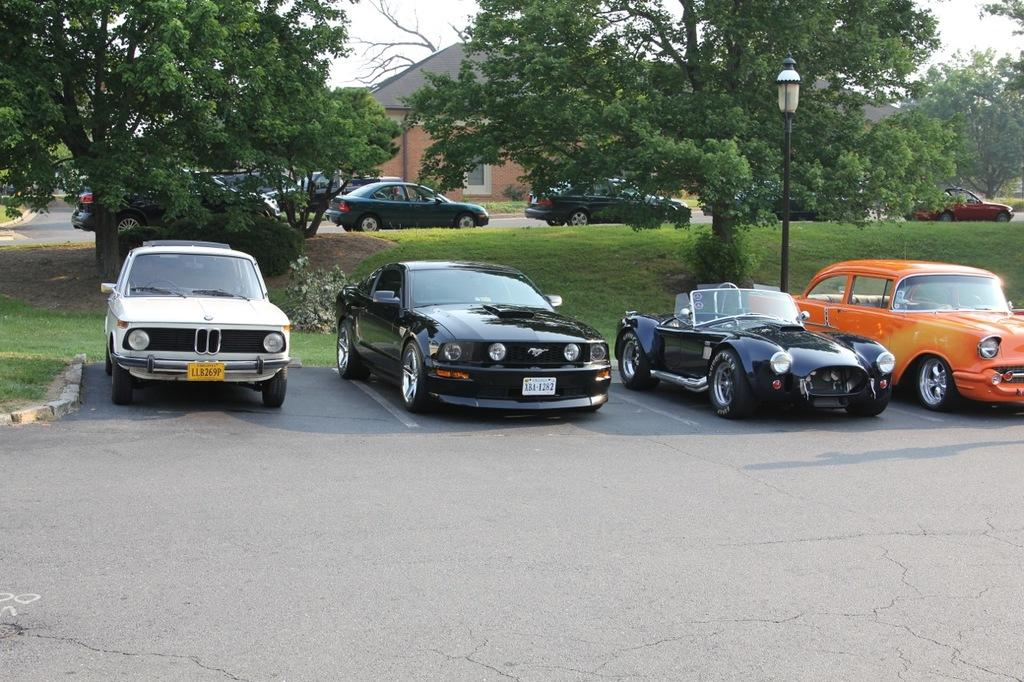What type of vehicles are on the road in the image? There are cars on the road in the image. What is located beside the cars? There is a light, a metal rod, and trees beside the cars. What can be seen in the background of the image? There is a house in the background of the image. What level of expertise is required to drive the cars in the image? The image does not provide information about the level of expertise required to drive the cars, as it only shows the cars on the road. 